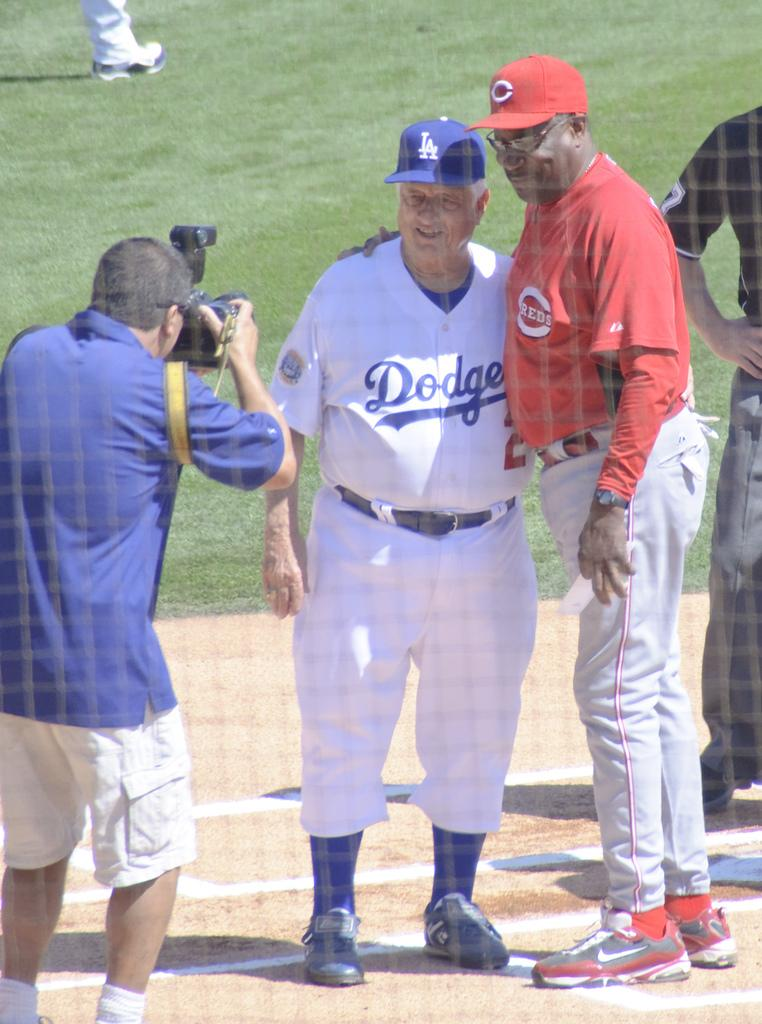<image>
Render a clear and concise summary of the photo. Two former managers for the Dodgers and Reds, take a picture. 